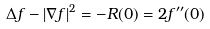<formula> <loc_0><loc_0><loc_500><loc_500>\Delta f - | \nabla f | ^ { 2 } = - R ( 0 ) = 2 f ^ { \prime \prime } ( 0 )</formula> 